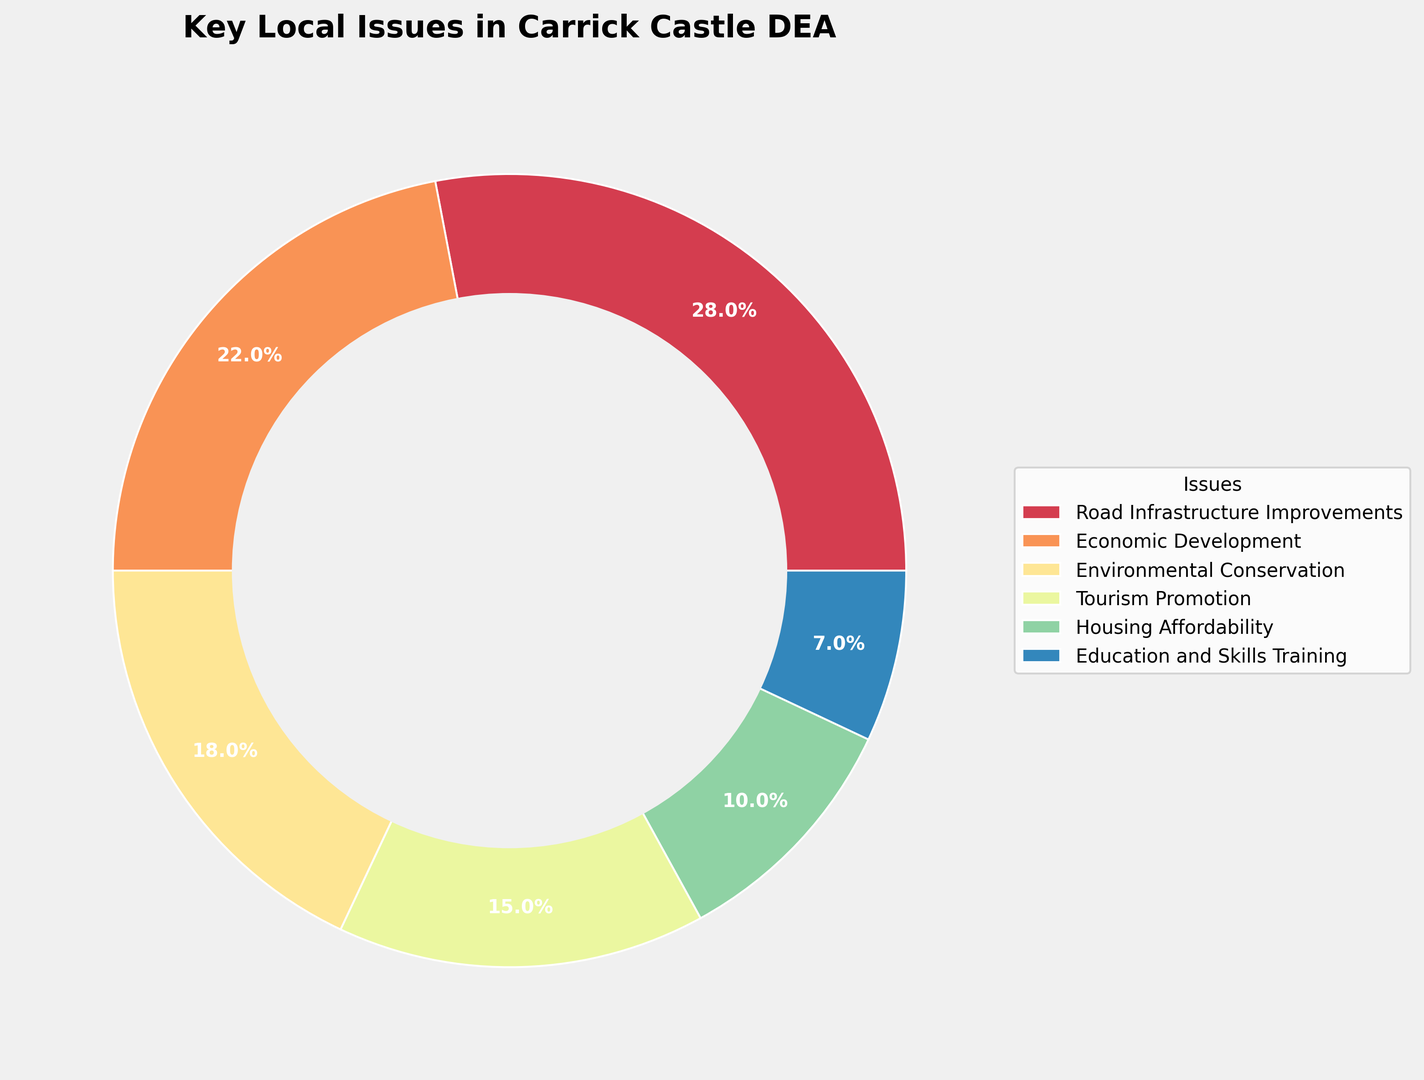Which issue has the highest percentage of public opinion in Carrick Castle DEA? The figure shows the breakdown of public opinion on key local issues. Road Infrastructure Improvements is depicted as the largest section of the ring chart, indicating it has the highest percentage.
Answer: Road Infrastructure Improvements What is the combined percentage of public opinion on Economic Development and Tourism Promotion? To find the combined percentage, add the percentages for Economic Development (22%) and Tourism Promotion (15%): 22% + 15% = 37%.
Answer: 37% Which issues together make up less than 20% of public opinion? The figure shows that Education and Skills Training (7%) and Housing Affordability (10%) are the two smallest sections. Together, their percentages add up to 7% + 10% = 17%.
Answer: Education and Skills Training and Housing Affordability Is the public opinion on Environmental Conservation greater than that on Housing Affordability? The figure shows that Environmental Conservation has a percentage of 18%, while Housing Affordability has 10%. Since 18% is greater than 10%, the public opinion on Environmental Conservation is indeed greater.
Answer: Yes What is the difference in public opinion percentage between Economic Development and Housing Affordability? Subtract the percentage for Housing Affordability (10%) from the percentage for Economic Development (22%): 22% - 10% = 12%.
Answer: 12% Which issue has the least public support? The figure shows that Education and Skills Training is the smallest segment of the ring chart, which indicates it has the least public support at 7%.
Answer: Education and Skills Training What percentage of public opinion is focused on non-economic issues (excluding Economic Development)? To find this, add the percentages of all issues excluding Economic Development: Road Infrastructure Improvements (28%) + Environmental Conservation (18%) + Tourism Promotion (15%) + Housing Affordability (10%) + Education and Skills Training (7%) = 78%.
Answer: 78% If support for Tourism Promotion increases by 5% and support for Road Infrastructure Improvements decreases by the same amount, what would their new percentages be? Add 5% to Tourism Promotion’s current percentage (15% + 5% = 20%) and subtract 5% from Road Infrastructure Improvements’ current percentage (28% - 5% = 23%).
Answer: 20% for Tourism Promotion and 23% for Road Infrastructure Improvements 